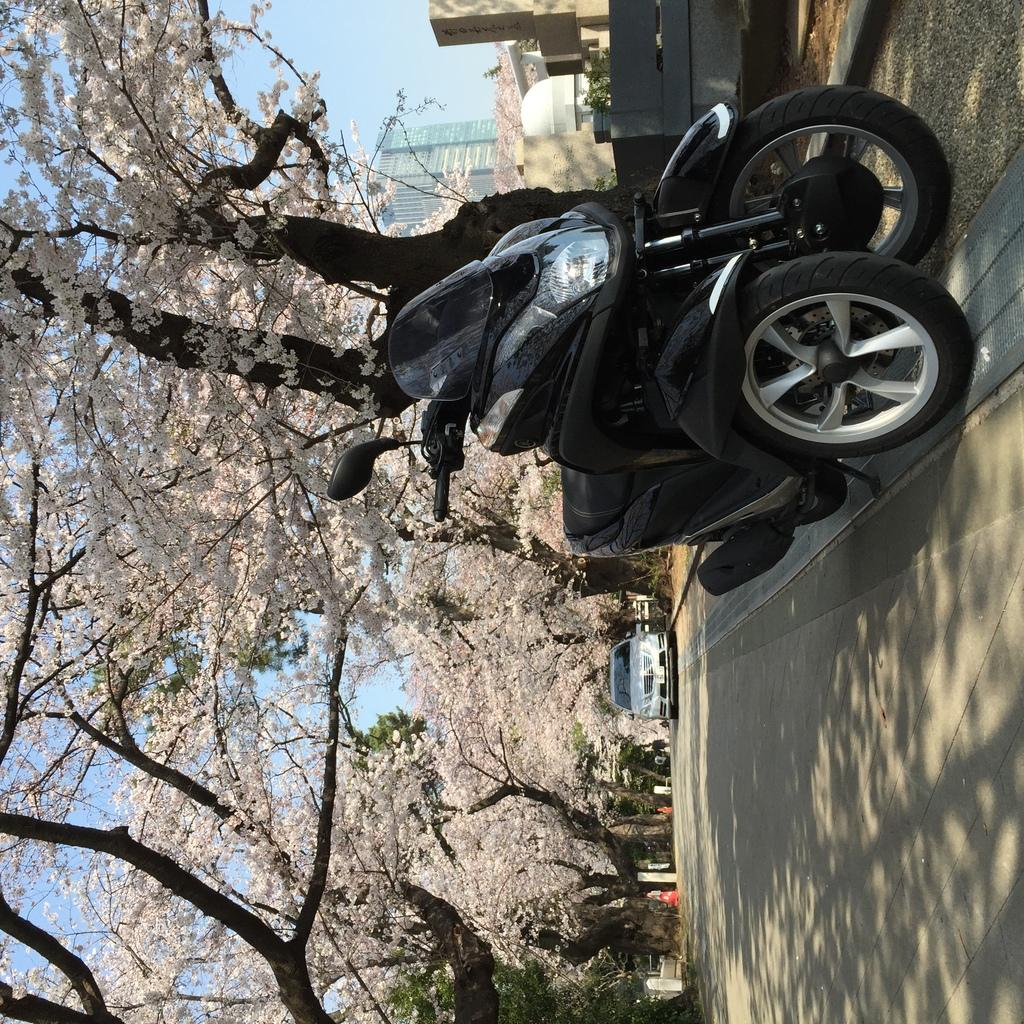How is the image oriented? The image is tilted. What can be seen in the sky in the image? There is a sky visible in the image. What type of natural vegetation is present in the image? There are trees in the image. Can any man-made structures be identified in the image? Yes, there is at least one building in the image. What type of transportation is visible on the road in the image? There are vehicles on the road in the image. What is the weather like in the image? It appears to be a sunny day in the image. What type of straw is being used to drink in the image? There is no straw or drinking activity present in the image. How many fingers are visible in the image? There are no fingers visible in the image. 